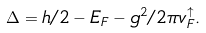<formula> <loc_0><loc_0><loc_500><loc_500>\Delta = h / 2 - E _ { F } - g ^ { 2 } / 2 \pi v ^ { \uparrow } _ { F } .</formula> 